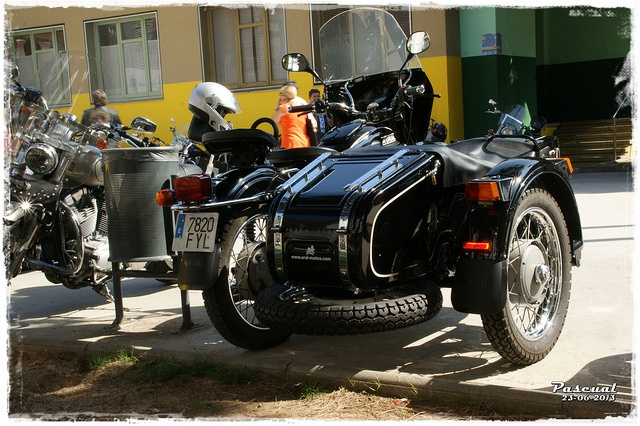Describe the objects in this image and their specific colors. I can see motorcycle in white, black, gray, darkgray, and ivory tones, motorcycle in white, black, gray, darkgray, and lightgray tones, motorcycle in white, black, gray, darkgray, and maroon tones, people in white, red, orange, khaki, and tan tones, and people in white, gray, black, and tan tones in this image. 